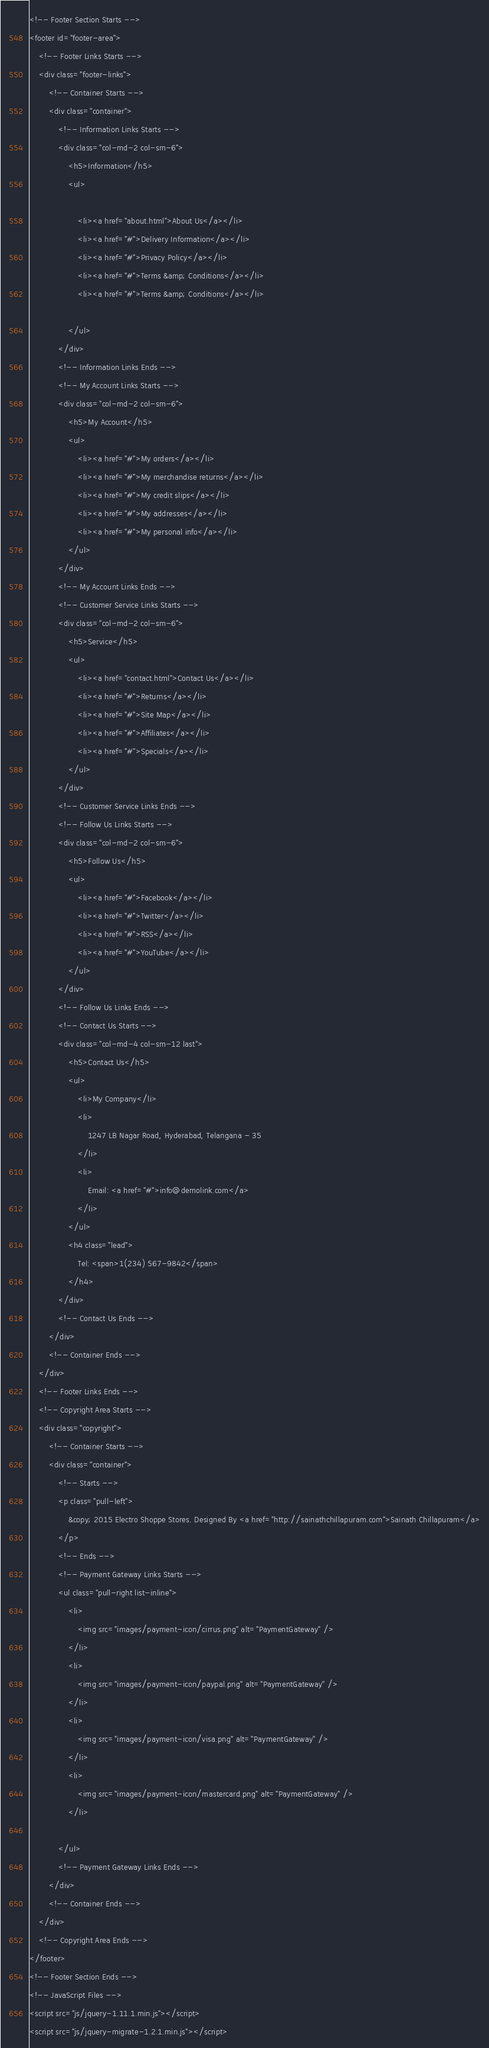<code> <loc_0><loc_0><loc_500><loc_500><_PHP_><!-- Footer Section Starts -->
<footer id="footer-area">
    <!-- Footer Links Starts -->
    <div class="footer-links">
        <!-- Container Starts -->
        <div class="container">
            <!-- Information Links Starts -->
            <div class="col-md-2 col-sm-6">
                <h5>Information</h5>
                <ul>

                    <li><a href="about.html">About Us</a></li>
                    <li><a href="#">Delivery Information</a></li>
                    <li><a href="#">Privacy Policy</a></li>
                    <li><a href="#">Terms &amp; Conditions</a></li>
                    <li><a href="#">Terms &amp; Conditions</a></li>

                </ul>
            </div>
            <!-- Information Links Ends -->
            <!-- My Account Links Starts -->
            <div class="col-md-2 col-sm-6">
                <h5>My Account</h5>
                <ul>
                    <li><a href="#">My orders</a></li>
                    <li><a href="#">My merchandise returns</a></li>
                    <li><a href="#">My credit slips</a></li>
                    <li><a href="#">My addresses</a></li>
                    <li><a href="#">My personal info</a></li>
                </ul>
            </div>
            <!-- My Account Links Ends -->
            <!-- Customer Service Links Starts -->
            <div class="col-md-2 col-sm-6">
                <h5>Service</h5>
                <ul>
                    <li><a href="contact.html">Contact Us</a></li>
                    <li><a href="#">Returns</a></li>
                    <li><a href="#">Site Map</a></li>
                    <li><a href="#">Affiliates</a></li>
                    <li><a href="#">Specials</a></li>
                </ul>
            </div>
            <!-- Customer Service Links Ends -->
            <!-- Follow Us Links Starts -->
            <div class="col-md-2 col-sm-6">
                <h5>Follow Us</h5>
                <ul>
                    <li><a href="#">Facebook</a></li>
                    <li><a href="#">Twitter</a></li>
                    <li><a href="#">RSS</a></li>
                    <li><a href="#">YouTube</a></li>
                </ul>
            </div>
            <!-- Follow Us Links Ends -->
            <!-- Contact Us Starts -->
            <div class="col-md-4 col-sm-12 last">
                <h5>Contact Us</h5>
                <ul>
                    <li>My Company</li>
                    <li>
                        1247 LB Nagar Road, Hyderabad, Telangana - 35
                    </li>
                    <li>
                        Email: <a href="#">info@demolink.com</a>
                    </li>
                </ul>
                <h4 class="lead">
                    Tel: <span>1(234) 567-9842</span>
                </h4>
            </div>
            <!-- Contact Us Ends -->
        </div>
        <!-- Container Ends -->
    </div>
    <!-- Footer Links Ends -->
    <!-- Copyright Area Starts -->
    <div class="copyright">
        <!-- Container Starts -->
        <div class="container">
            <!-- Starts -->
            <p class="pull-left">
                &copy; 2015 Electro Shoppe Stores. Designed By <a href="http://sainathchillapuram.com">Sainath Chillapuram</a>
            </p>
            <!-- Ends -->
            <!-- Payment Gateway Links Starts -->
            <ul class="pull-right list-inline">
                <li>
                    <img src="images/payment-icon/cirrus.png" alt="PaymentGateway" />
                </li>
                <li>
                    <img src="images/payment-icon/paypal.png" alt="PaymentGateway" />
                </li>
                <li>
                    <img src="images/payment-icon/visa.png" alt="PaymentGateway" />
                </li>
                <li>
                    <img src="images/payment-icon/mastercard.png" alt="PaymentGateway" />
                </li>

            </ul>
            <!-- Payment Gateway Links Ends -->
        </div>
        <!-- Container Ends -->
    </div>
    <!-- Copyright Area Ends -->
</footer>
<!-- Footer Section Ends -->
<!-- JavaScript Files -->
<script src="js/jquery-1.11.1.min.js"></script>
<script src="js/jquery-migrate-1.2.1.min.js"></script></code> 